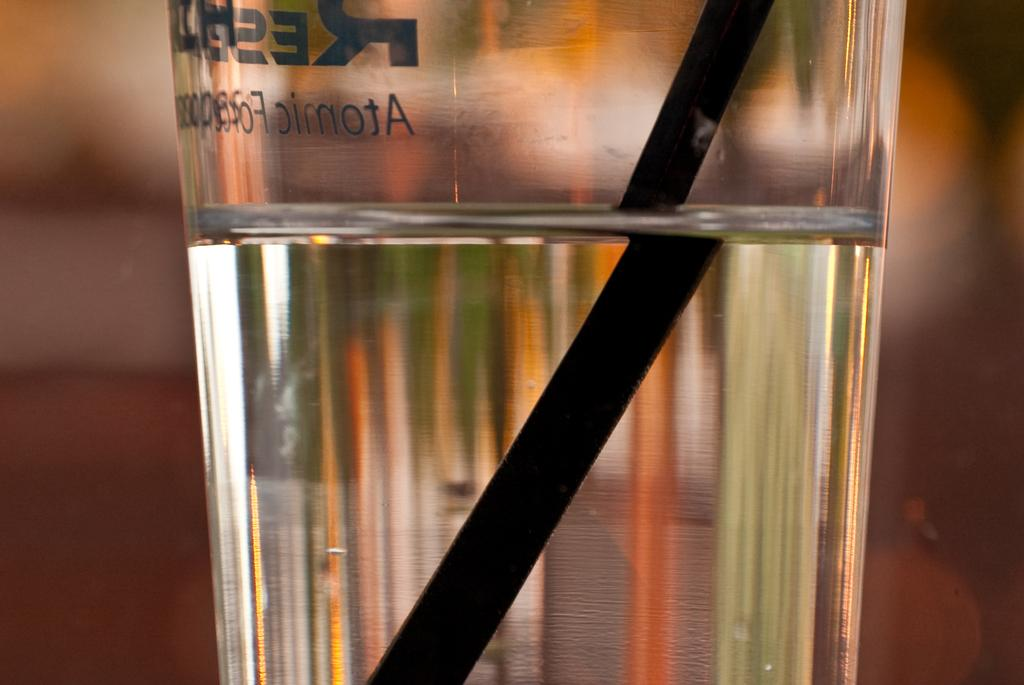<image>
Write a terse but informative summary of the picture. Glass of water in Atomic glass with a black straw in it 